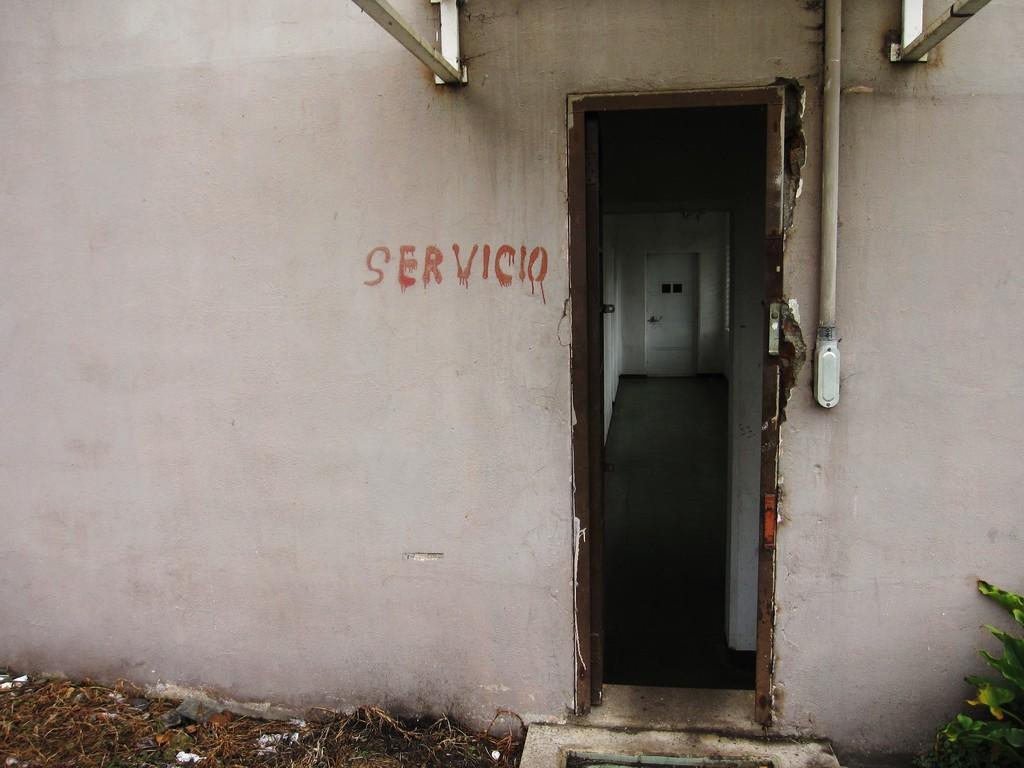How would you summarize this image in a sentence or two? In this image we can see rods, pipe and some text on the wall. At the bottom of the image, we can see the land, dry grass and a plant. There is a door and walls in the middle of the image. 